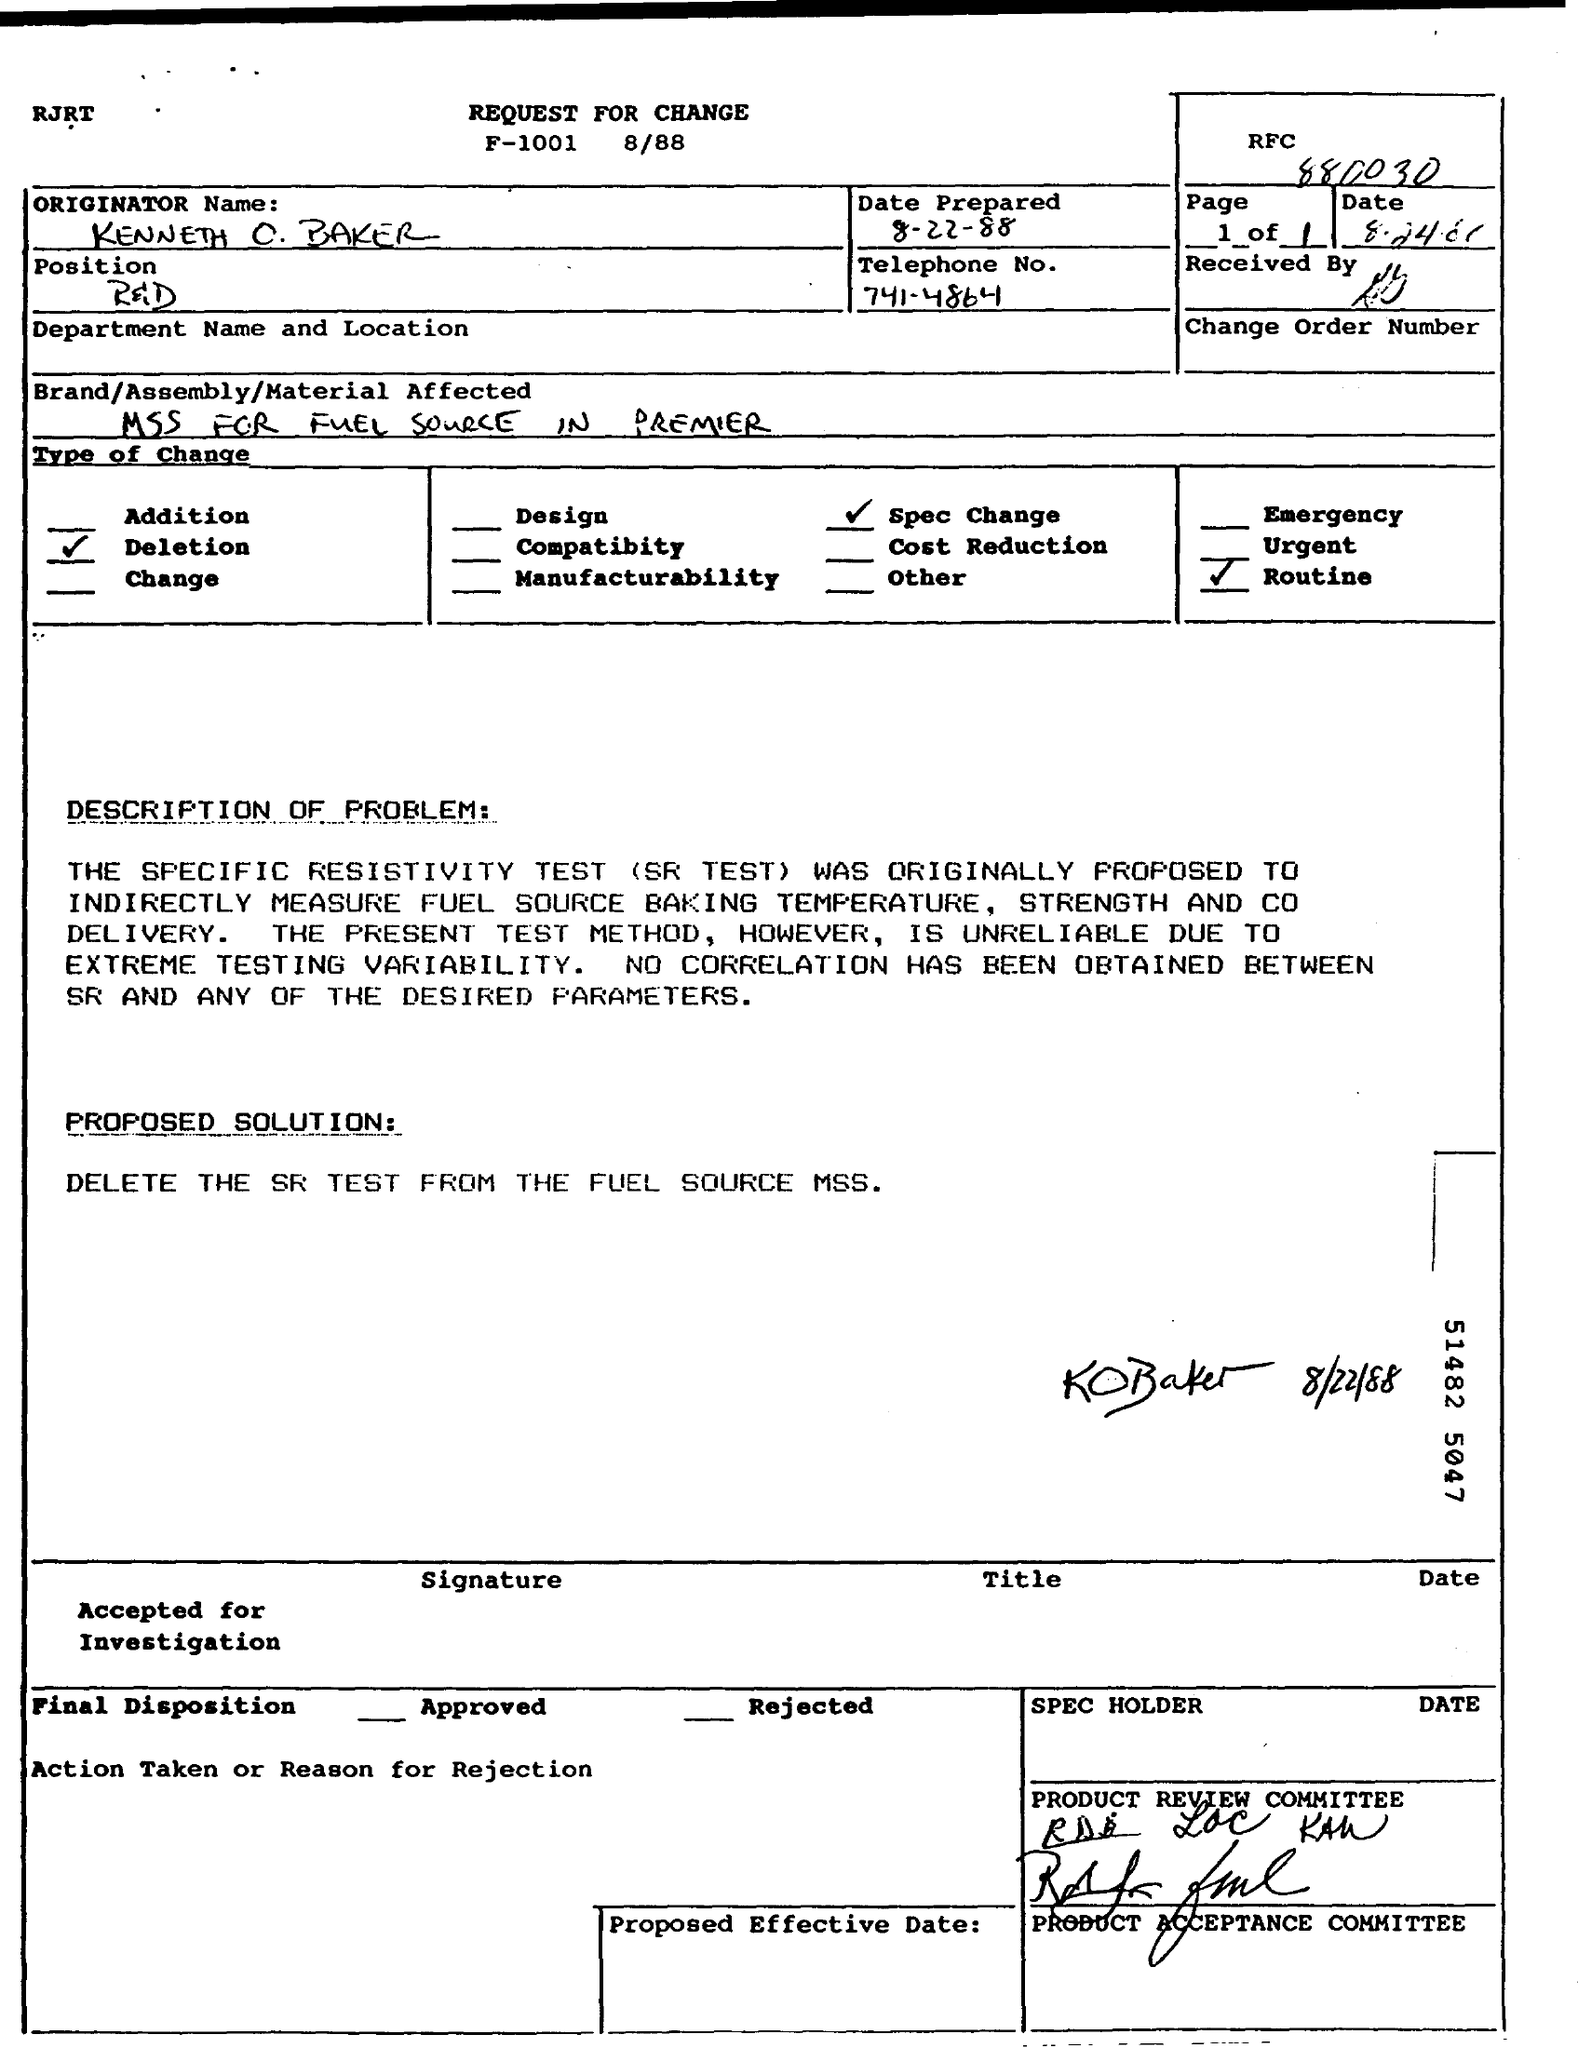What is the Originator Name given in the document?
Ensure brevity in your answer.  Kenneth o. baker. What is the Date prepared as per the document?
Your answer should be very brief. 8-22-88. What is the Telephone No mentioned in this document?
Provide a short and direct response. 741-4864. What is the position of KENNETH O. BAKER?
Provide a succinct answer. R&d. What is the  Brand/Assembly/Material Affected as per the dcoument?
Your response must be concise. Mss for fuel source in premier. What is the proposed solution given in the document?
Ensure brevity in your answer.  DELETE THE SR TEST FROM THE FUEL SOURCE MSS. What is the fullform of SR TEST?
Provide a succinct answer. Specific Resistivity Test. 